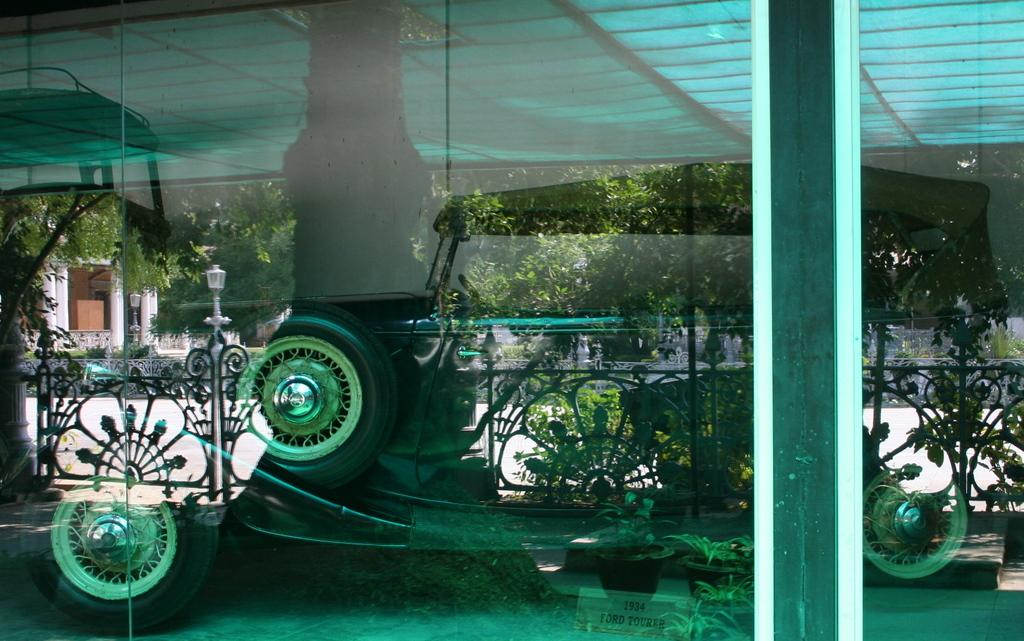What type of surface is the image depicting? The image appears to be a glass window. What can be seen through the window? Trees, poles, lights, plants, and a fence are visible through the window. Can you describe the building visible in the image? There is a building visible in the image, but its specific features are not mentioned in the provided facts. What type of oatmeal is being served to the lawyer in the image? There is no lawyer or oatmeal present in the image; it is a glass window with various objects and elements visible through it. 